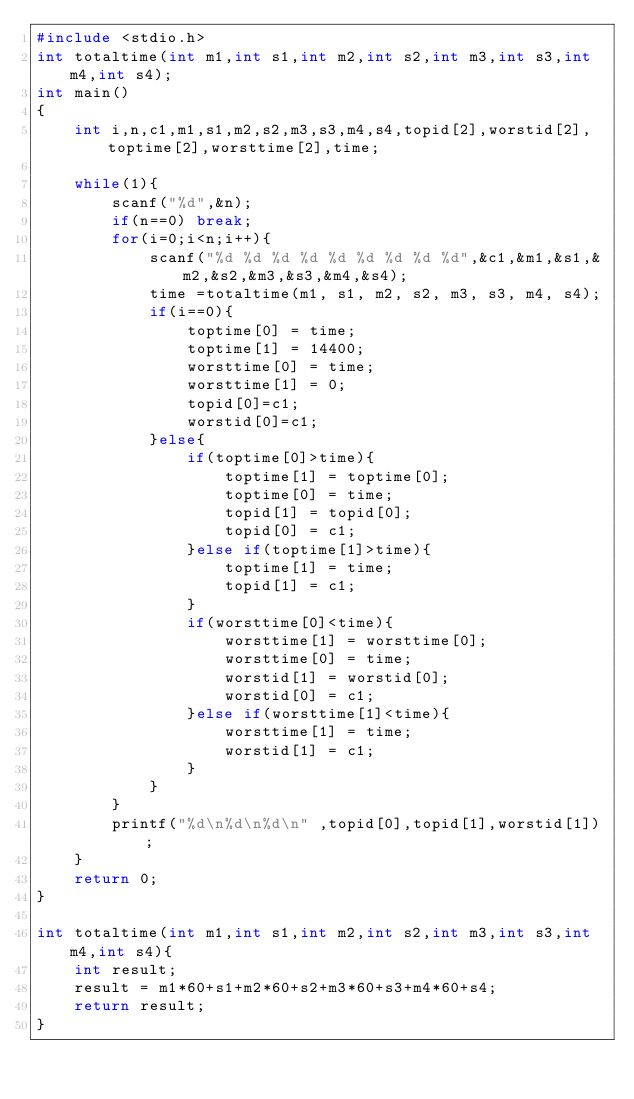Convert code to text. <code><loc_0><loc_0><loc_500><loc_500><_C_>#include <stdio.h>
int totaltime(int m1,int s1,int m2,int s2,int m3,int s3,int m4,int s4);
int main()
{
    int i,n,c1,m1,s1,m2,s2,m3,s3,m4,s4,topid[2],worstid[2],toptime[2],worsttime[2],time;

    while(1){
        scanf("%d",&n);
        if(n==0) break;
        for(i=0;i<n;i++){
            scanf("%d %d %d %d %d %d %d %d %d",&c1,&m1,&s1,&m2,&s2,&m3,&s3,&m4,&s4);
            time =totaltime(m1, s1, m2, s2, m3, s3, m4, s4);
            if(i==0){
                toptime[0] = time;
                toptime[1] = 14400;
                worsttime[0] = time;
                worsttime[1] = 0;
                topid[0]=c1;
                worstid[0]=c1;
            }else{
                if(toptime[0]>time){
                    toptime[1] = toptime[0];
                    toptime[0] = time;
                    topid[1] = topid[0];
                    topid[0] = c1;
                }else if(toptime[1]>time){
                    toptime[1] = time;
                    topid[1] = c1;
                }
                if(worsttime[0]<time){
                    worsttime[1] = worsttime[0];
                    worsttime[0] = time;
                    worstid[1] = worstid[0];
                    worstid[0] = c1;
                }else if(worsttime[1]<time){
                    worsttime[1] = time;
                    worstid[1] = c1;
                }
            }
        }
        printf("%d\n%d\n%d\n" ,topid[0],topid[1],worstid[1]);
    }
    return 0;
}

int totaltime(int m1,int s1,int m2,int s2,int m3,int s3,int m4,int s4){
    int result;
    result = m1*60+s1+m2*60+s2+m3*60+s3+m4*60+s4;
    return result;
}</code> 